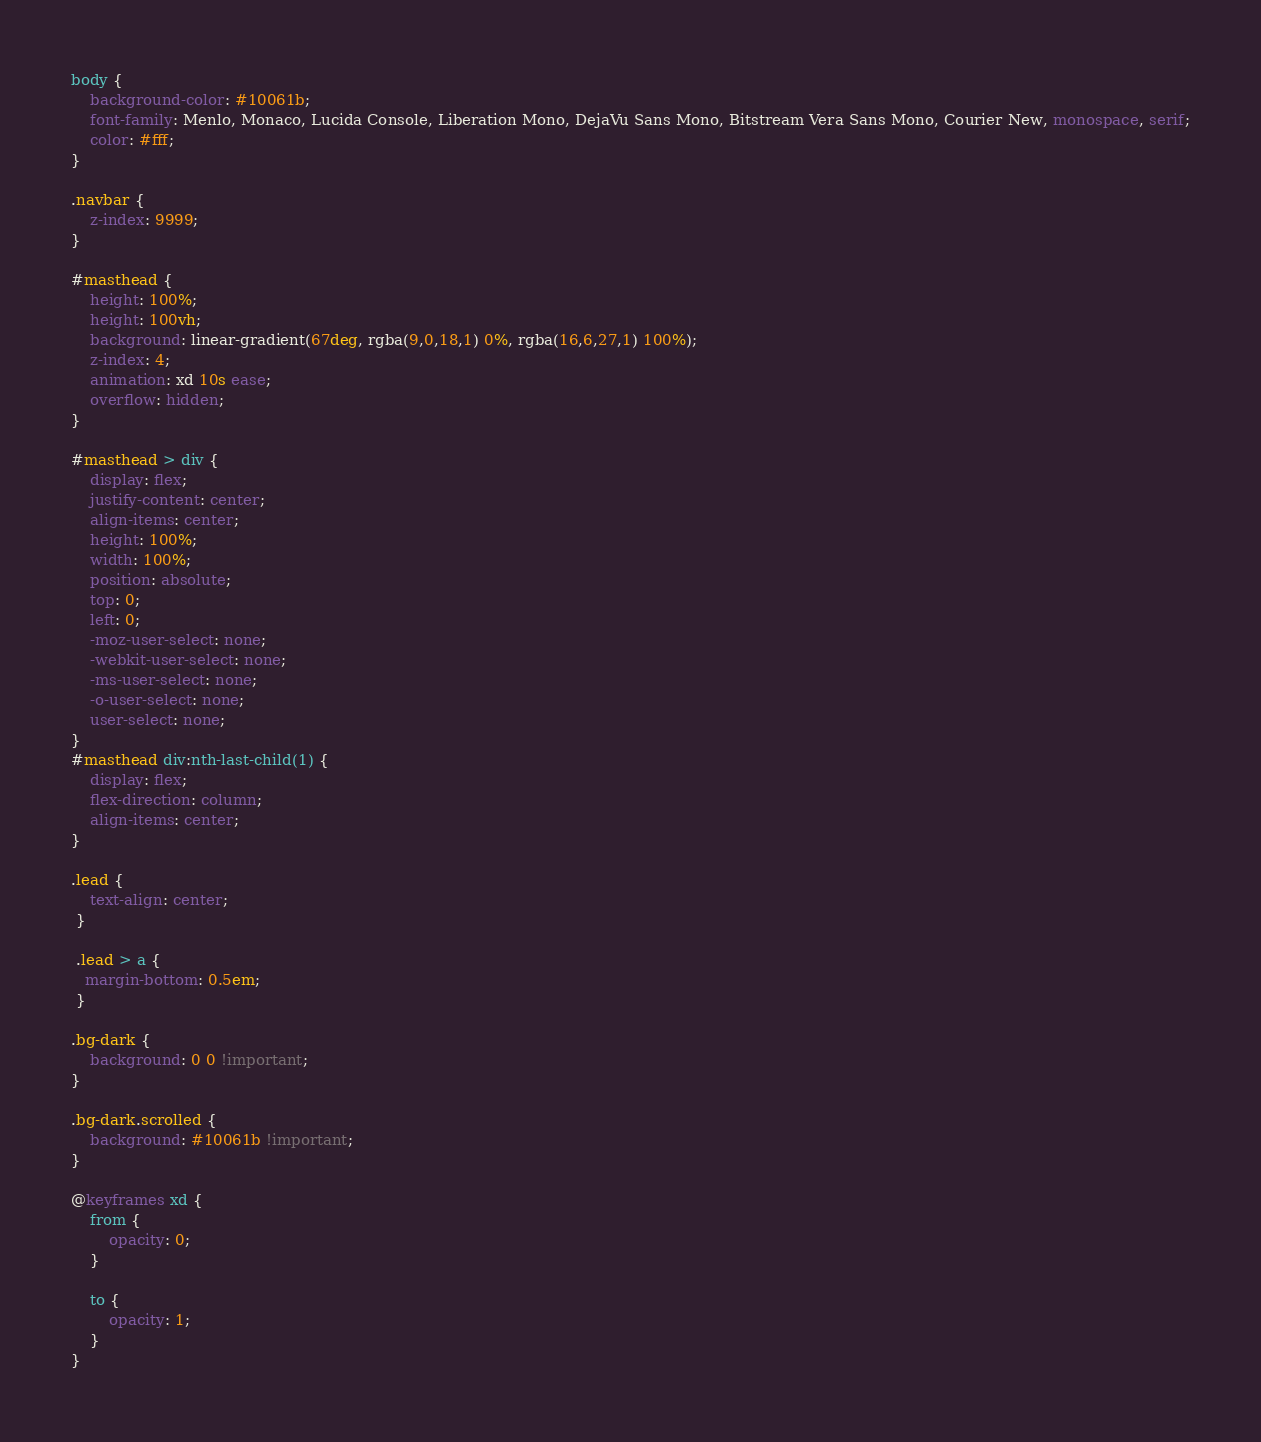Convert code to text. <code><loc_0><loc_0><loc_500><loc_500><_CSS_>body {
    background-color: #10061b;
    font-family: Menlo, Monaco, Lucida Console, Liberation Mono, DejaVu Sans Mono, Bitstream Vera Sans Mono, Courier New, monospace, serif;
    color: #fff;
}

.navbar {
    z-index: 9999;
}

#masthead {
    height: 100%;
    height: 100vh;
    background: linear-gradient(67deg, rgba(9,0,18,1) 0%, rgba(16,6,27,1) 100%);
    z-index: 4;
    animation: xd 10s ease;
    overflow: hidden;
}

#masthead > div {
    display: flex;
    justify-content: center;
    align-items: center;
    height: 100%;
    width: 100%;
    position: absolute;
    top: 0;
    left: 0;
    -moz-user-select: none;
    -webkit-user-select: none;
    -ms-user-select: none;
    -o-user-select: none;
    user-select: none; 
}
#masthead div:nth-last-child(1) {
    display: flex;
    flex-direction: column;
    align-items: center;
}

.lead {
    text-align: center;
 }
 
 .lead > a {
   margin-bottom: 0.5em;
 }

.bg-dark {
    background: 0 0 !important;
}

.bg-dark.scrolled {
    background: #10061b !important;
}

@keyframes xd {
    from {
        opacity: 0;
    }

    to {
        opacity: 1;
    }
}</code> 